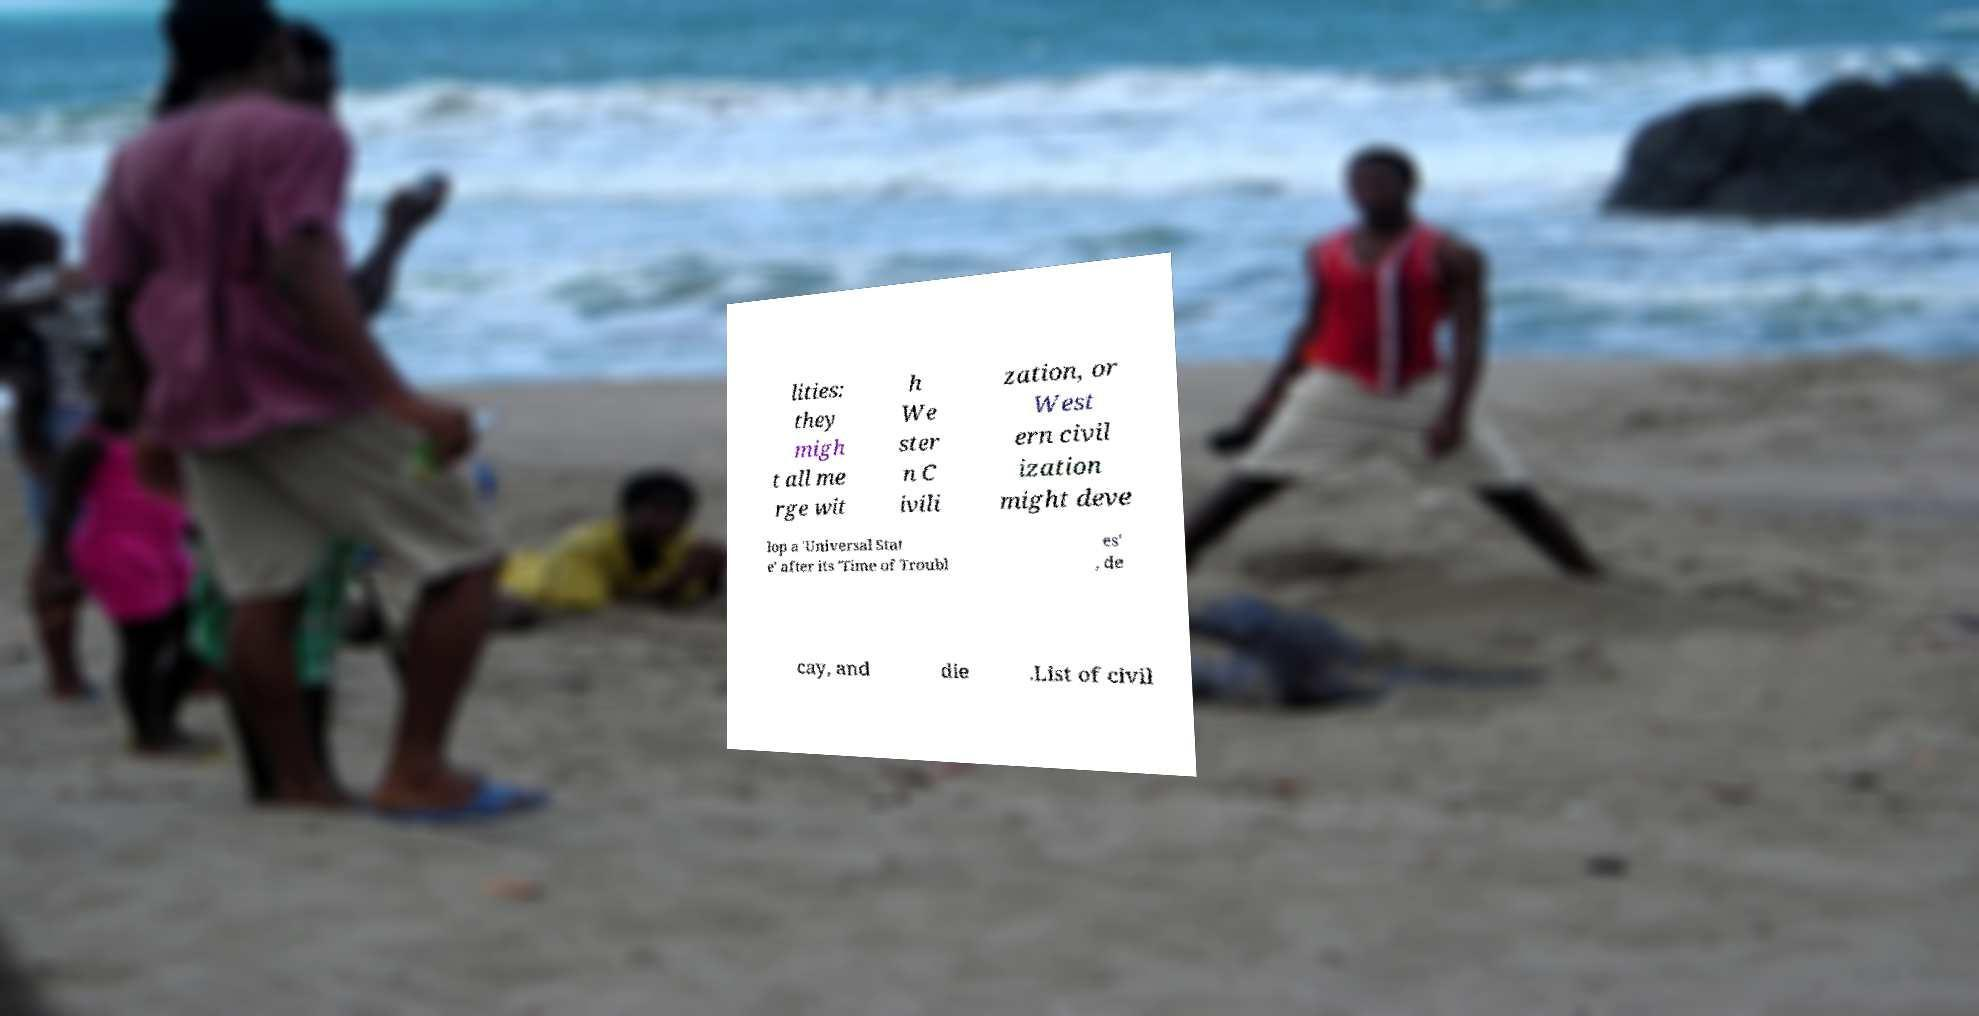Can you accurately transcribe the text from the provided image for me? lities: they migh t all me rge wit h We ster n C ivili zation, or West ern civil ization might deve lop a 'Universal Stat e' after its 'Time of Troubl es' , de cay, and die .List of civil 